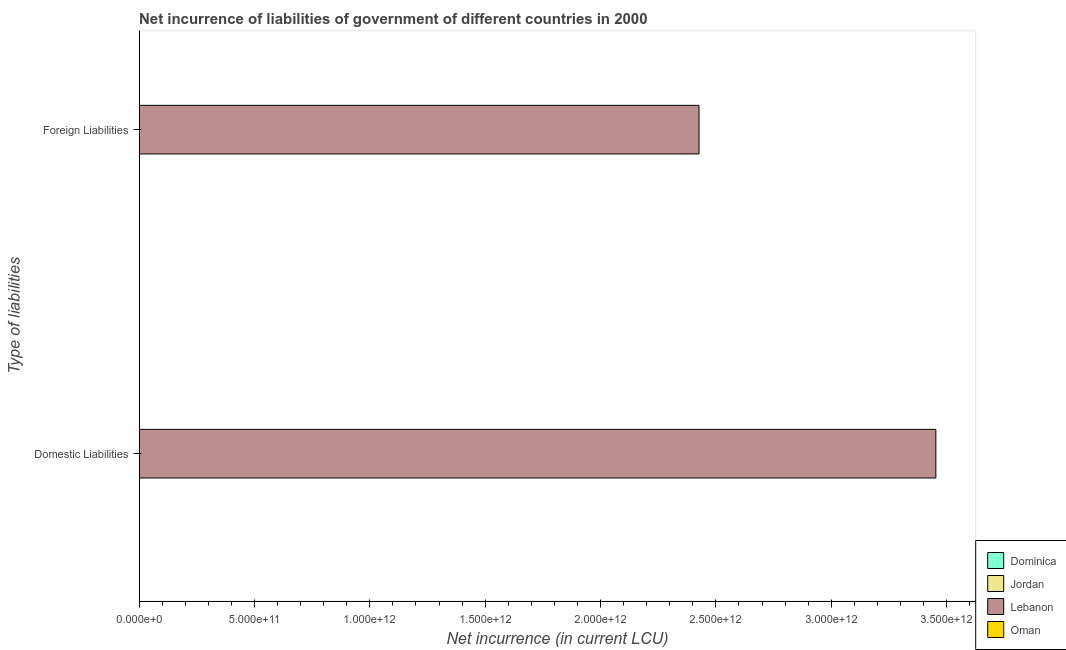How many different coloured bars are there?
Keep it short and to the point. 3. Are the number of bars per tick equal to the number of legend labels?
Keep it short and to the point. No. Are the number of bars on each tick of the Y-axis equal?
Your answer should be compact. No. How many bars are there on the 2nd tick from the bottom?
Your answer should be very brief. 2. What is the label of the 2nd group of bars from the top?
Your response must be concise. Domestic Liabilities. What is the net incurrence of domestic liabilities in Jordan?
Your response must be concise. 1.09e+08. Across all countries, what is the maximum net incurrence of foreign liabilities?
Make the answer very short. 2.43e+12. In which country was the net incurrence of domestic liabilities maximum?
Your answer should be very brief. Lebanon. What is the total net incurrence of foreign liabilities in the graph?
Give a very brief answer. 2.43e+12. What is the difference between the net incurrence of domestic liabilities in Jordan and the net incurrence of foreign liabilities in Lebanon?
Give a very brief answer. -2.43e+12. What is the average net incurrence of foreign liabilities per country?
Your answer should be very brief. 6.07e+11. What is the difference between the net incurrence of foreign liabilities and net incurrence of domestic liabilities in Dominica?
Offer a terse response. 2.90e+07. In how many countries, is the net incurrence of domestic liabilities greater than 500000000000 LCU?
Give a very brief answer. 1. What is the ratio of the net incurrence of foreign liabilities in Lebanon to that in Dominica?
Offer a very short reply. 4.67e+04. In how many countries, is the net incurrence of domestic liabilities greater than the average net incurrence of domestic liabilities taken over all countries?
Provide a succinct answer. 1. How many countries are there in the graph?
Offer a very short reply. 4. What is the difference between two consecutive major ticks on the X-axis?
Give a very brief answer. 5.00e+11. Are the values on the major ticks of X-axis written in scientific E-notation?
Your answer should be very brief. Yes. Does the graph contain any zero values?
Provide a short and direct response. Yes. Where does the legend appear in the graph?
Offer a very short reply. Bottom right. How are the legend labels stacked?
Your answer should be very brief. Vertical. What is the title of the graph?
Your answer should be very brief. Net incurrence of liabilities of government of different countries in 2000. Does "West Bank and Gaza" appear as one of the legend labels in the graph?
Keep it short and to the point. No. What is the label or title of the X-axis?
Give a very brief answer. Net incurrence (in current LCU). What is the label or title of the Y-axis?
Provide a succinct answer. Type of liabilities. What is the Net incurrence (in current LCU) of Dominica in Domestic Liabilities?
Your response must be concise. 2.30e+07. What is the Net incurrence (in current LCU) in Jordan in Domestic Liabilities?
Offer a terse response. 1.09e+08. What is the Net incurrence (in current LCU) of Lebanon in Domestic Liabilities?
Your answer should be very brief. 3.45e+12. What is the Net incurrence (in current LCU) of Dominica in Foreign Liabilities?
Provide a succinct answer. 5.20e+07. What is the Net incurrence (in current LCU) of Jordan in Foreign Liabilities?
Keep it short and to the point. 0. What is the Net incurrence (in current LCU) of Lebanon in Foreign Liabilities?
Provide a succinct answer. 2.43e+12. What is the Net incurrence (in current LCU) in Oman in Foreign Liabilities?
Your answer should be very brief. 0. Across all Type of liabilities, what is the maximum Net incurrence (in current LCU) in Dominica?
Offer a very short reply. 5.20e+07. Across all Type of liabilities, what is the maximum Net incurrence (in current LCU) in Jordan?
Give a very brief answer. 1.09e+08. Across all Type of liabilities, what is the maximum Net incurrence (in current LCU) of Lebanon?
Make the answer very short. 3.45e+12. Across all Type of liabilities, what is the minimum Net incurrence (in current LCU) of Dominica?
Your response must be concise. 2.30e+07. Across all Type of liabilities, what is the minimum Net incurrence (in current LCU) in Jordan?
Provide a short and direct response. 0. Across all Type of liabilities, what is the minimum Net incurrence (in current LCU) of Lebanon?
Your answer should be very brief. 2.43e+12. What is the total Net incurrence (in current LCU) of Dominica in the graph?
Make the answer very short. 7.50e+07. What is the total Net incurrence (in current LCU) of Jordan in the graph?
Your response must be concise. 1.09e+08. What is the total Net incurrence (in current LCU) in Lebanon in the graph?
Offer a terse response. 5.88e+12. What is the difference between the Net incurrence (in current LCU) of Dominica in Domestic Liabilities and that in Foreign Liabilities?
Provide a short and direct response. -2.90e+07. What is the difference between the Net incurrence (in current LCU) in Lebanon in Domestic Liabilities and that in Foreign Liabilities?
Keep it short and to the point. 1.03e+12. What is the difference between the Net incurrence (in current LCU) of Dominica in Domestic Liabilities and the Net incurrence (in current LCU) of Lebanon in Foreign Liabilities?
Keep it short and to the point. -2.43e+12. What is the difference between the Net incurrence (in current LCU) in Jordan in Domestic Liabilities and the Net incurrence (in current LCU) in Lebanon in Foreign Liabilities?
Ensure brevity in your answer.  -2.43e+12. What is the average Net incurrence (in current LCU) in Dominica per Type of liabilities?
Keep it short and to the point. 3.75e+07. What is the average Net incurrence (in current LCU) of Jordan per Type of liabilities?
Your answer should be very brief. 5.44e+07. What is the average Net incurrence (in current LCU) in Lebanon per Type of liabilities?
Give a very brief answer. 2.94e+12. What is the average Net incurrence (in current LCU) of Oman per Type of liabilities?
Provide a short and direct response. 0. What is the difference between the Net incurrence (in current LCU) of Dominica and Net incurrence (in current LCU) of Jordan in Domestic Liabilities?
Your answer should be very brief. -8.58e+07. What is the difference between the Net incurrence (in current LCU) in Dominica and Net incurrence (in current LCU) in Lebanon in Domestic Liabilities?
Provide a short and direct response. -3.45e+12. What is the difference between the Net incurrence (in current LCU) in Jordan and Net incurrence (in current LCU) in Lebanon in Domestic Liabilities?
Provide a succinct answer. -3.45e+12. What is the difference between the Net incurrence (in current LCU) in Dominica and Net incurrence (in current LCU) in Lebanon in Foreign Liabilities?
Provide a succinct answer. -2.43e+12. What is the ratio of the Net incurrence (in current LCU) in Dominica in Domestic Liabilities to that in Foreign Liabilities?
Ensure brevity in your answer.  0.44. What is the ratio of the Net incurrence (in current LCU) in Lebanon in Domestic Liabilities to that in Foreign Liabilities?
Your answer should be compact. 1.42. What is the difference between the highest and the second highest Net incurrence (in current LCU) in Dominica?
Offer a very short reply. 2.90e+07. What is the difference between the highest and the second highest Net incurrence (in current LCU) in Lebanon?
Give a very brief answer. 1.03e+12. What is the difference between the highest and the lowest Net incurrence (in current LCU) of Dominica?
Your answer should be compact. 2.90e+07. What is the difference between the highest and the lowest Net incurrence (in current LCU) in Jordan?
Make the answer very short. 1.09e+08. What is the difference between the highest and the lowest Net incurrence (in current LCU) of Lebanon?
Offer a very short reply. 1.03e+12. 